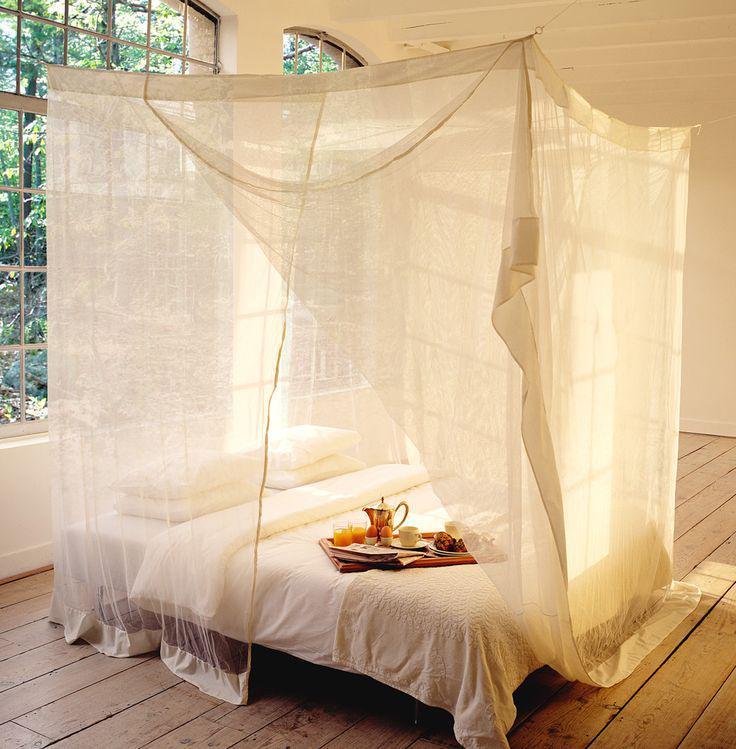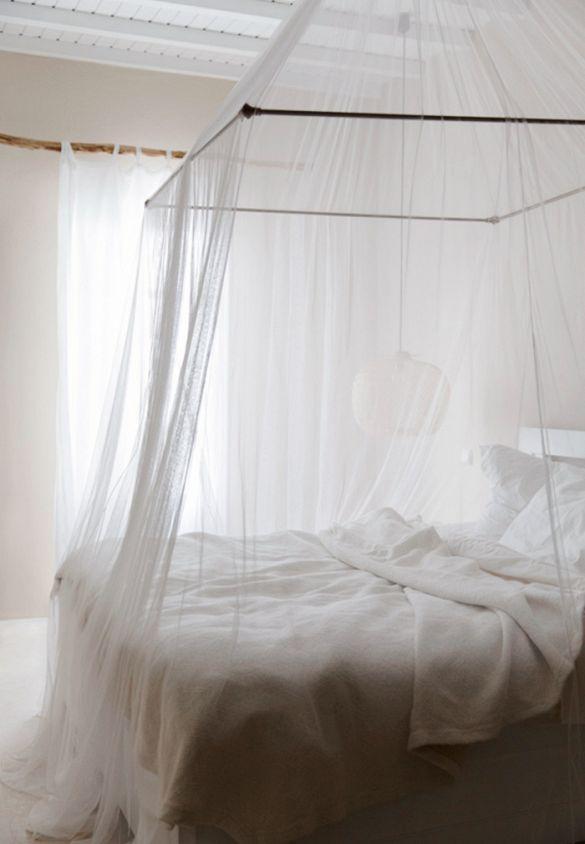The first image is the image on the left, the second image is the image on the right. Considering the images on both sides, is "There is a rounded net sitting over the bed in the image on the right." valid? Answer yes or no. No. The first image is the image on the left, the second image is the image on the right. For the images shown, is this caption "Drapes cover half of the bed in the left image and a tent like dome covers the whole bed in the right image." true? Answer yes or no. No. 